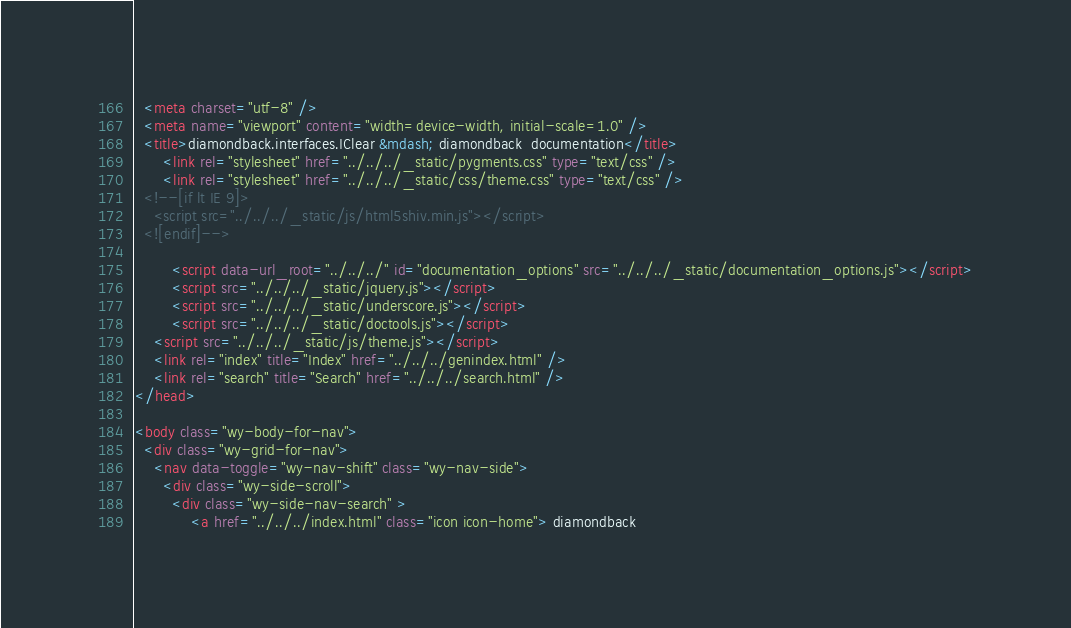<code> <loc_0><loc_0><loc_500><loc_500><_HTML_>  <meta charset="utf-8" />
  <meta name="viewport" content="width=device-width, initial-scale=1.0" />
  <title>diamondback.interfaces.IClear &mdash; diamondback  documentation</title>
      <link rel="stylesheet" href="../../../_static/pygments.css" type="text/css" />
      <link rel="stylesheet" href="../../../_static/css/theme.css" type="text/css" />
  <!--[if lt IE 9]>
    <script src="../../../_static/js/html5shiv.min.js"></script>
  <![endif]-->
  
        <script data-url_root="../../../" id="documentation_options" src="../../../_static/documentation_options.js"></script>
        <script src="../../../_static/jquery.js"></script>
        <script src="../../../_static/underscore.js"></script>
        <script src="../../../_static/doctools.js"></script>
    <script src="../../../_static/js/theme.js"></script>
    <link rel="index" title="Index" href="../../../genindex.html" />
    <link rel="search" title="Search" href="../../../search.html" /> 
</head>

<body class="wy-body-for-nav"> 
  <div class="wy-grid-for-nav">
    <nav data-toggle="wy-nav-shift" class="wy-nav-side">
      <div class="wy-side-scroll">
        <div class="wy-side-nav-search" >
            <a href="../../../index.html" class="icon icon-home"> diamondback</code> 